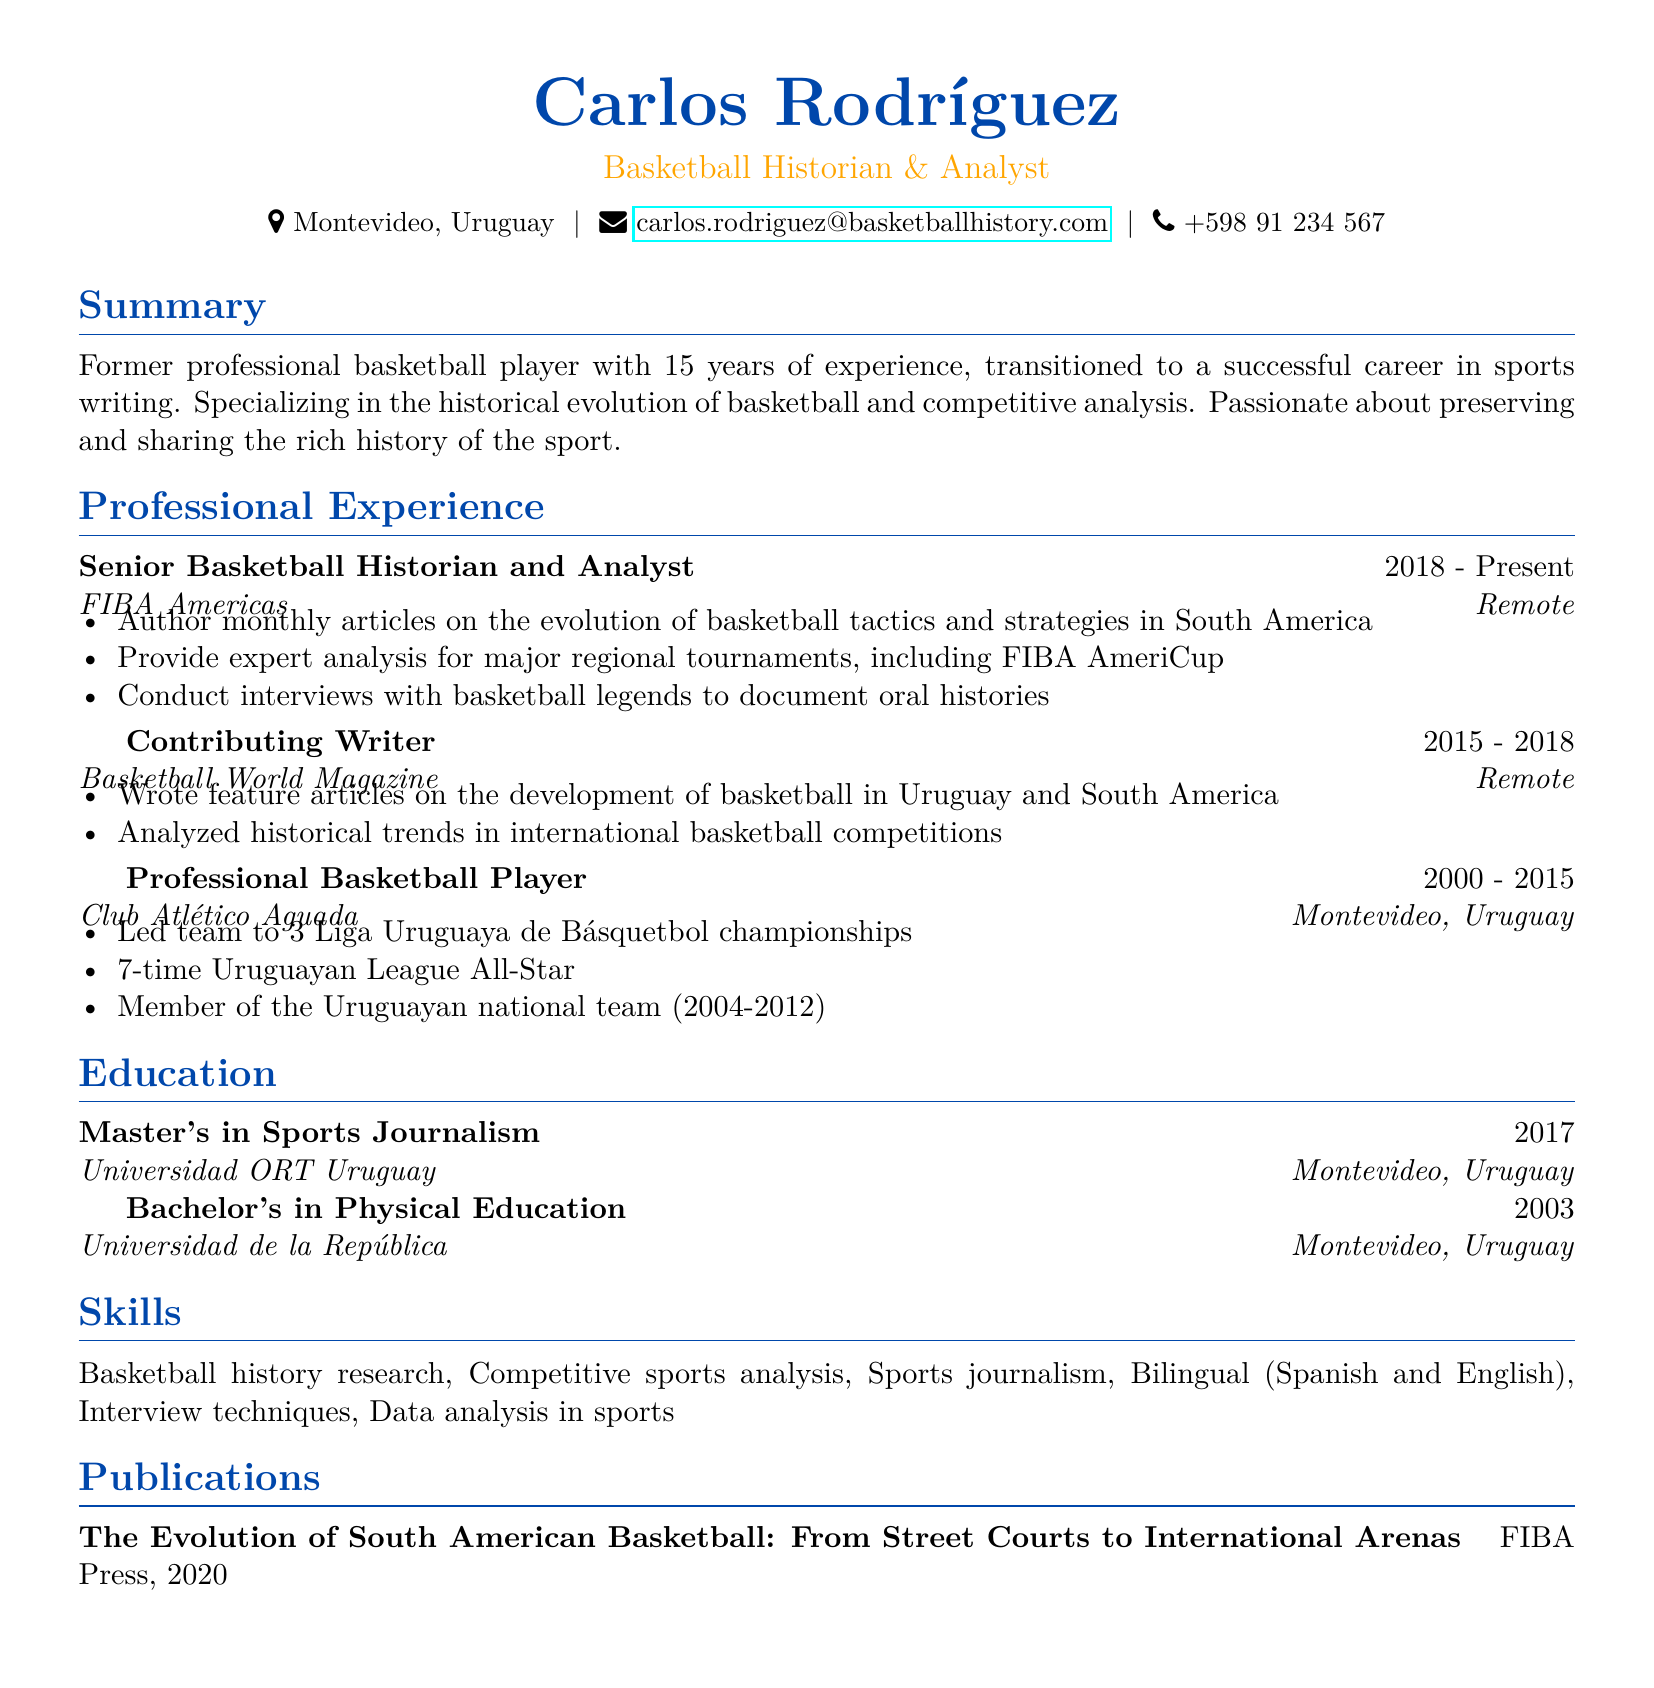What is the name of the individual? The document presents Carlos Rodríguez as the individual highlighted in the resume.
Answer: Carlos Rodríguez What was Carlos Rodríguez's position at FIBA Americas? The resume specifies that Carlos Rodríguez is a Senior Basketball Historian and Analyst at FIBA Americas.
Answer: Senior Basketball Historian and Analyst How many years did Carlos play professional basketball? The resume indicates that he played professional basketball for 15 years.
Answer: 15 years In which year did Carlos graduate with a Master's in Sports Journalism? The document states that he obtained his Master's degree in the year 2017.
Answer: 2017 How many Liga Uruguaya de Básquetbol championships did Carlos lead his team to? The resume mentions that Carlos led his team to 3 Liga Uruguaya de Básquetbol championships.
Answer: 3 What is the title of Carlos's publication? The document indicates that the title of Carlos's publication is "The Evolution of South American Basketball: From Street Courts to International Arenas".
Answer: The Evolution of South American Basketball: From Street Courts to International Arenas How many times was Carlos an Uruguayan League All-Star? The resume states that Carlos was a 7-time Uruguayan League All-Star.
Answer: 7-time What is one of Carlos's skills listed in the resume? The document identifies several skills, one being basketball history research.
Answer: Basketball history research Which team did Carlos play for during his professional career? The resume specifically mentions that he played for Club Atlético Aguada.
Answer: Club Atlético Aguada 